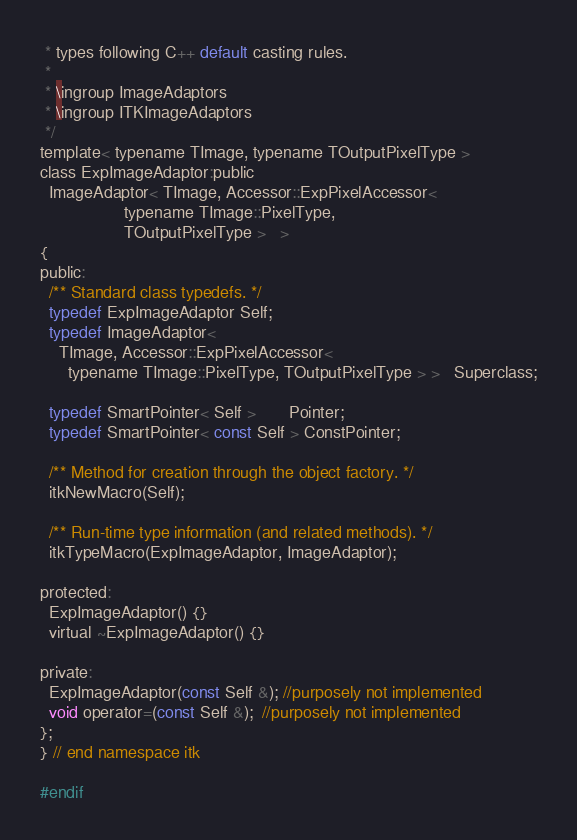Convert code to text. <code><loc_0><loc_0><loc_500><loc_500><_C_> * types following C++ default casting rules.
 *
 * \ingroup ImageAdaptors
 * \ingroup ITKImageAdaptors
 */
template< typename TImage, typename TOutputPixelType >
class ExpImageAdaptor:public
  ImageAdaptor< TImage, Accessor::ExpPixelAccessor<
                  typename TImage::PixelType,
                  TOutputPixelType >   >
{
public:
  /** Standard class typedefs. */
  typedef ExpImageAdaptor Self;
  typedef ImageAdaptor<
    TImage, Accessor::ExpPixelAccessor<
      typename TImage::PixelType, TOutputPixelType > >   Superclass;

  typedef SmartPointer< Self >       Pointer;
  typedef SmartPointer< const Self > ConstPointer;

  /** Method for creation through the object factory. */
  itkNewMacro(Self);

  /** Run-time type information (and related methods). */
  itkTypeMacro(ExpImageAdaptor, ImageAdaptor);

protected:
  ExpImageAdaptor() {}
  virtual ~ExpImageAdaptor() {}

private:
  ExpImageAdaptor(const Self &); //purposely not implemented
  void operator=(const Self &);  //purposely not implemented
};
} // end namespace itk

#endif
</code> 